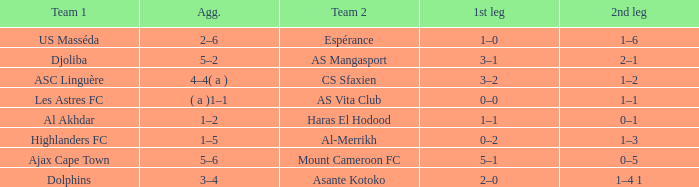What is the 2nd leg of team 1 Dolphins? 1–4 1. Could you help me parse every detail presented in this table? {'header': ['Team 1', 'Agg.', 'Team 2', '1st leg', '2nd leg'], 'rows': [['US Masséda', '2–6', 'Espérance', '1–0', '1–6'], ['Djoliba', '5–2', 'AS Mangasport', '3–1', '2–1'], ['ASC Linguère', '4–4( a )', 'CS Sfaxien', '3–2', '1–2'], ['Les Astres FC', '( a )1–1', 'AS Vita Club', '0–0', '1–1'], ['Al Akhdar', '1–2', 'Haras El Hodood', '1–1', '0–1'], ['Highlanders FC', '1–5', 'Al-Merrikh', '0–2', '1–3'], ['Ajax Cape Town', '5–6', 'Mount Cameroon FC', '5–1', '0–5'], ['Dolphins', '3–4', 'Asante Kotoko', '2–0', '1–4 1']]} 